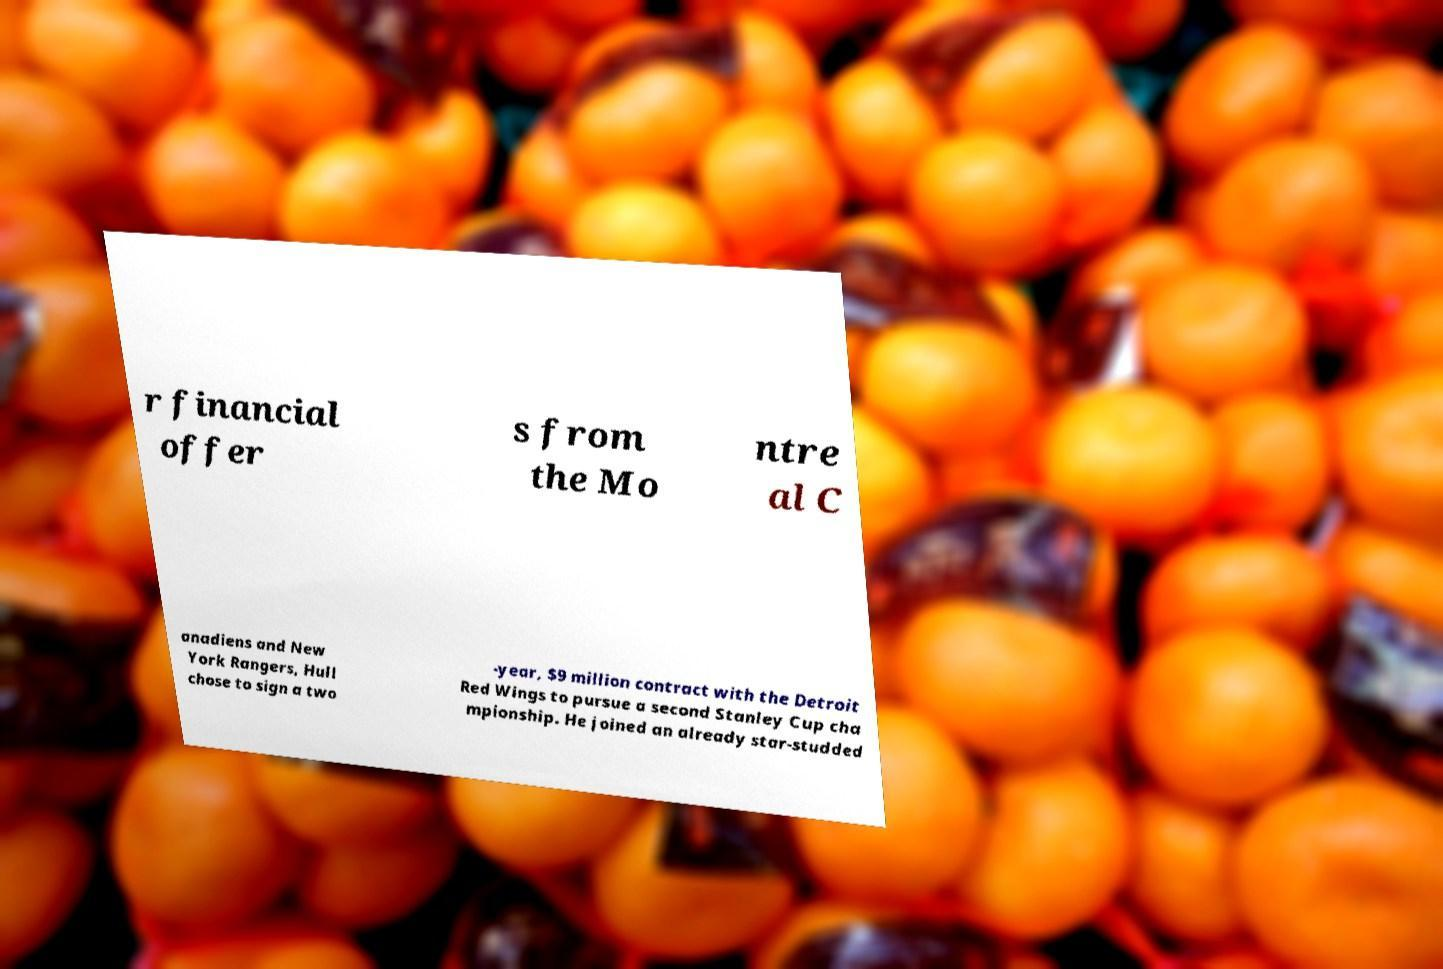Could you assist in decoding the text presented in this image and type it out clearly? r financial offer s from the Mo ntre al C anadiens and New York Rangers, Hull chose to sign a two -year, $9 million contract with the Detroit Red Wings to pursue a second Stanley Cup cha mpionship. He joined an already star-studded 